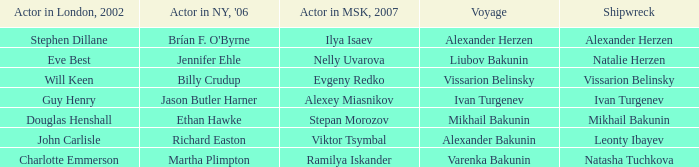Who was the Actor in the New York production in 2006 for the row with Ramilya Iskander performing in Moscow in 2007? Martha Plimpton. 